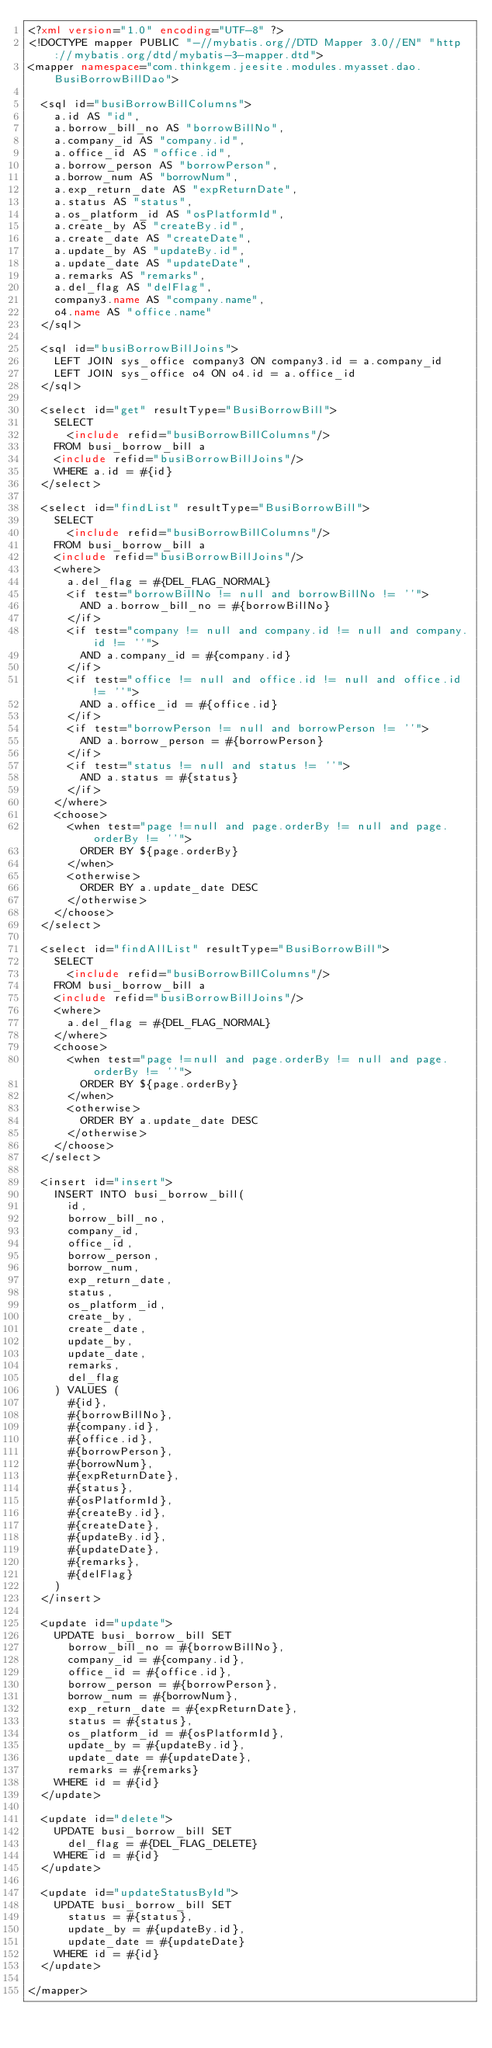Convert code to text. <code><loc_0><loc_0><loc_500><loc_500><_XML_><?xml version="1.0" encoding="UTF-8" ?>
<!DOCTYPE mapper PUBLIC "-//mybatis.org//DTD Mapper 3.0//EN" "http://mybatis.org/dtd/mybatis-3-mapper.dtd">
<mapper namespace="com.thinkgem.jeesite.modules.myasset.dao.BusiBorrowBillDao">
    
	<sql id="busiBorrowBillColumns">
		a.id AS "id",
		a.borrow_bill_no AS "borrowBillNo",
		a.company_id AS "company.id",
		a.office_id AS "office.id",
		a.borrow_person AS "borrowPerson",
		a.borrow_num AS "borrowNum",
		a.exp_return_date AS "expReturnDate",
		a.status AS "status",
		a.os_platform_id AS "osPlatformId",
		a.create_by AS "createBy.id",
		a.create_date AS "createDate",
		a.update_by AS "updateBy.id",
		a.update_date AS "updateDate",
		a.remarks AS "remarks",
		a.del_flag AS "delFlag",
		company3.name AS "company.name",
		o4.name AS "office.name"
	</sql>
	
	<sql id="busiBorrowBillJoins">
		LEFT JOIN sys_office company3 ON company3.id = a.company_id
		LEFT JOIN sys_office o4 ON o4.id = a.office_id
	</sql>
    
	<select id="get" resultType="BusiBorrowBill">
		SELECT 
			<include refid="busiBorrowBillColumns"/>
		FROM busi_borrow_bill a
		<include refid="busiBorrowBillJoins"/>
		WHERE a.id = #{id}
	</select>
	
	<select id="findList" resultType="BusiBorrowBill">
		SELECT 
			<include refid="busiBorrowBillColumns"/>
		FROM busi_borrow_bill a
		<include refid="busiBorrowBillJoins"/>
		<where>
			a.del_flag = #{DEL_FLAG_NORMAL}
			<if test="borrowBillNo != null and borrowBillNo != ''">
				AND a.borrow_bill_no = #{borrowBillNo}
			</if>
			<if test="company != null and company.id != null and company.id != ''">
				AND a.company_id = #{company.id}
			</if>
			<if test="office != null and office.id != null and office.id != ''">
				AND a.office_id = #{office.id}
			</if>
			<if test="borrowPerson != null and borrowPerson != ''">
				AND a.borrow_person = #{borrowPerson}
			</if>
			<if test="status != null and status != ''">
				AND a.status = #{status}
			</if>
		</where>
		<choose>
			<when test="page !=null and page.orderBy != null and page.orderBy != ''">
				ORDER BY ${page.orderBy}
			</when>
			<otherwise>
				ORDER BY a.update_date DESC
			</otherwise>
		</choose>
	</select>
	
	<select id="findAllList" resultType="BusiBorrowBill">
		SELECT 
			<include refid="busiBorrowBillColumns"/>
		FROM busi_borrow_bill a
		<include refid="busiBorrowBillJoins"/>
		<where>
			a.del_flag = #{DEL_FLAG_NORMAL}
		</where>		
		<choose>
			<when test="page !=null and page.orderBy != null and page.orderBy != ''">
				ORDER BY ${page.orderBy}
			</when>
			<otherwise>
				ORDER BY a.update_date DESC
			</otherwise>
		</choose>
	</select>
	
	<insert id="insert">
		INSERT INTO busi_borrow_bill(
			id,
			borrow_bill_no,
			company_id,
			office_id,
			borrow_person,
			borrow_num,
			exp_return_date,
			status,
			os_platform_id,
			create_by,
			create_date,
			update_by,
			update_date,
			remarks,
			del_flag
		) VALUES (
			#{id},
			#{borrowBillNo},
			#{company.id},
			#{office.id},
			#{borrowPerson},
			#{borrowNum},
			#{expReturnDate},
			#{status},
			#{osPlatformId},
			#{createBy.id},
			#{createDate},
			#{updateBy.id},
			#{updateDate},
			#{remarks},
			#{delFlag}
		)
	</insert>
	
	<update id="update">
		UPDATE busi_borrow_bill SET 	
			borrow_bill_no = #{borrowBillNo},
			company_id = #{company.id},
			office_id = #{office.id},
			borrow_person = #{borrowPerson},
			borrow_num = #{borrowNum},
			exp_return_date = #{expReturnDate},
			status = #{status},
			os_platform_id = #{osPlatformId},
			update_by = #{updateBy.id},
			update_date = #{updateDate},
			remarks = #{remarks}
		WHERE id = #{id}
	</update>
	
	<update id="delete">
		UPDATE busi_borrow_bill SET 
			del_flag = #{DEL_FLAG_DELETE}
		WHERE id = #{id}
	</update>
	
	<update id="updateStatusById">
		UPDATE busi_borrow_bill SET 	
			status = #{status},
			update_by = #{updateBy.id},
			update_date = #{updateDate}
		WHERE id = #{id}
	</update>
	
</mapper></code> 